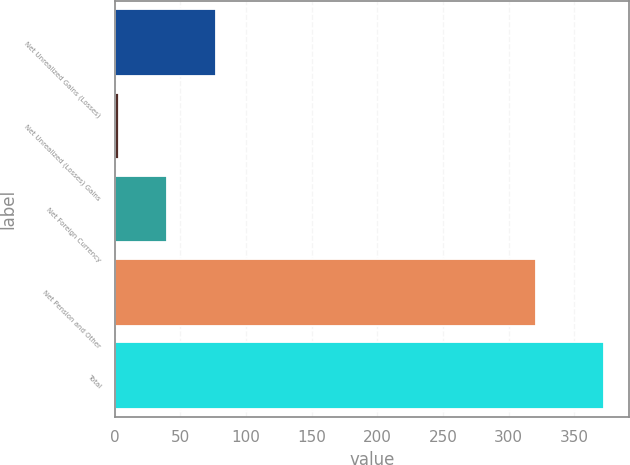Convert chart. <chart><loc_0><loc_0><loc_500><loc_500><bar_chart><fcel>Net Unrealized Gains (Losses)<fcel>Net Unrealized (Losses) Gains<fcel>Net Foreign Currency<fcel>Net Pension and Other<fcel>Total<nl><fcel>76.94<fcel>3<fcel>39.97<fcel>321.1<fcel>372.7<nl></chart> 